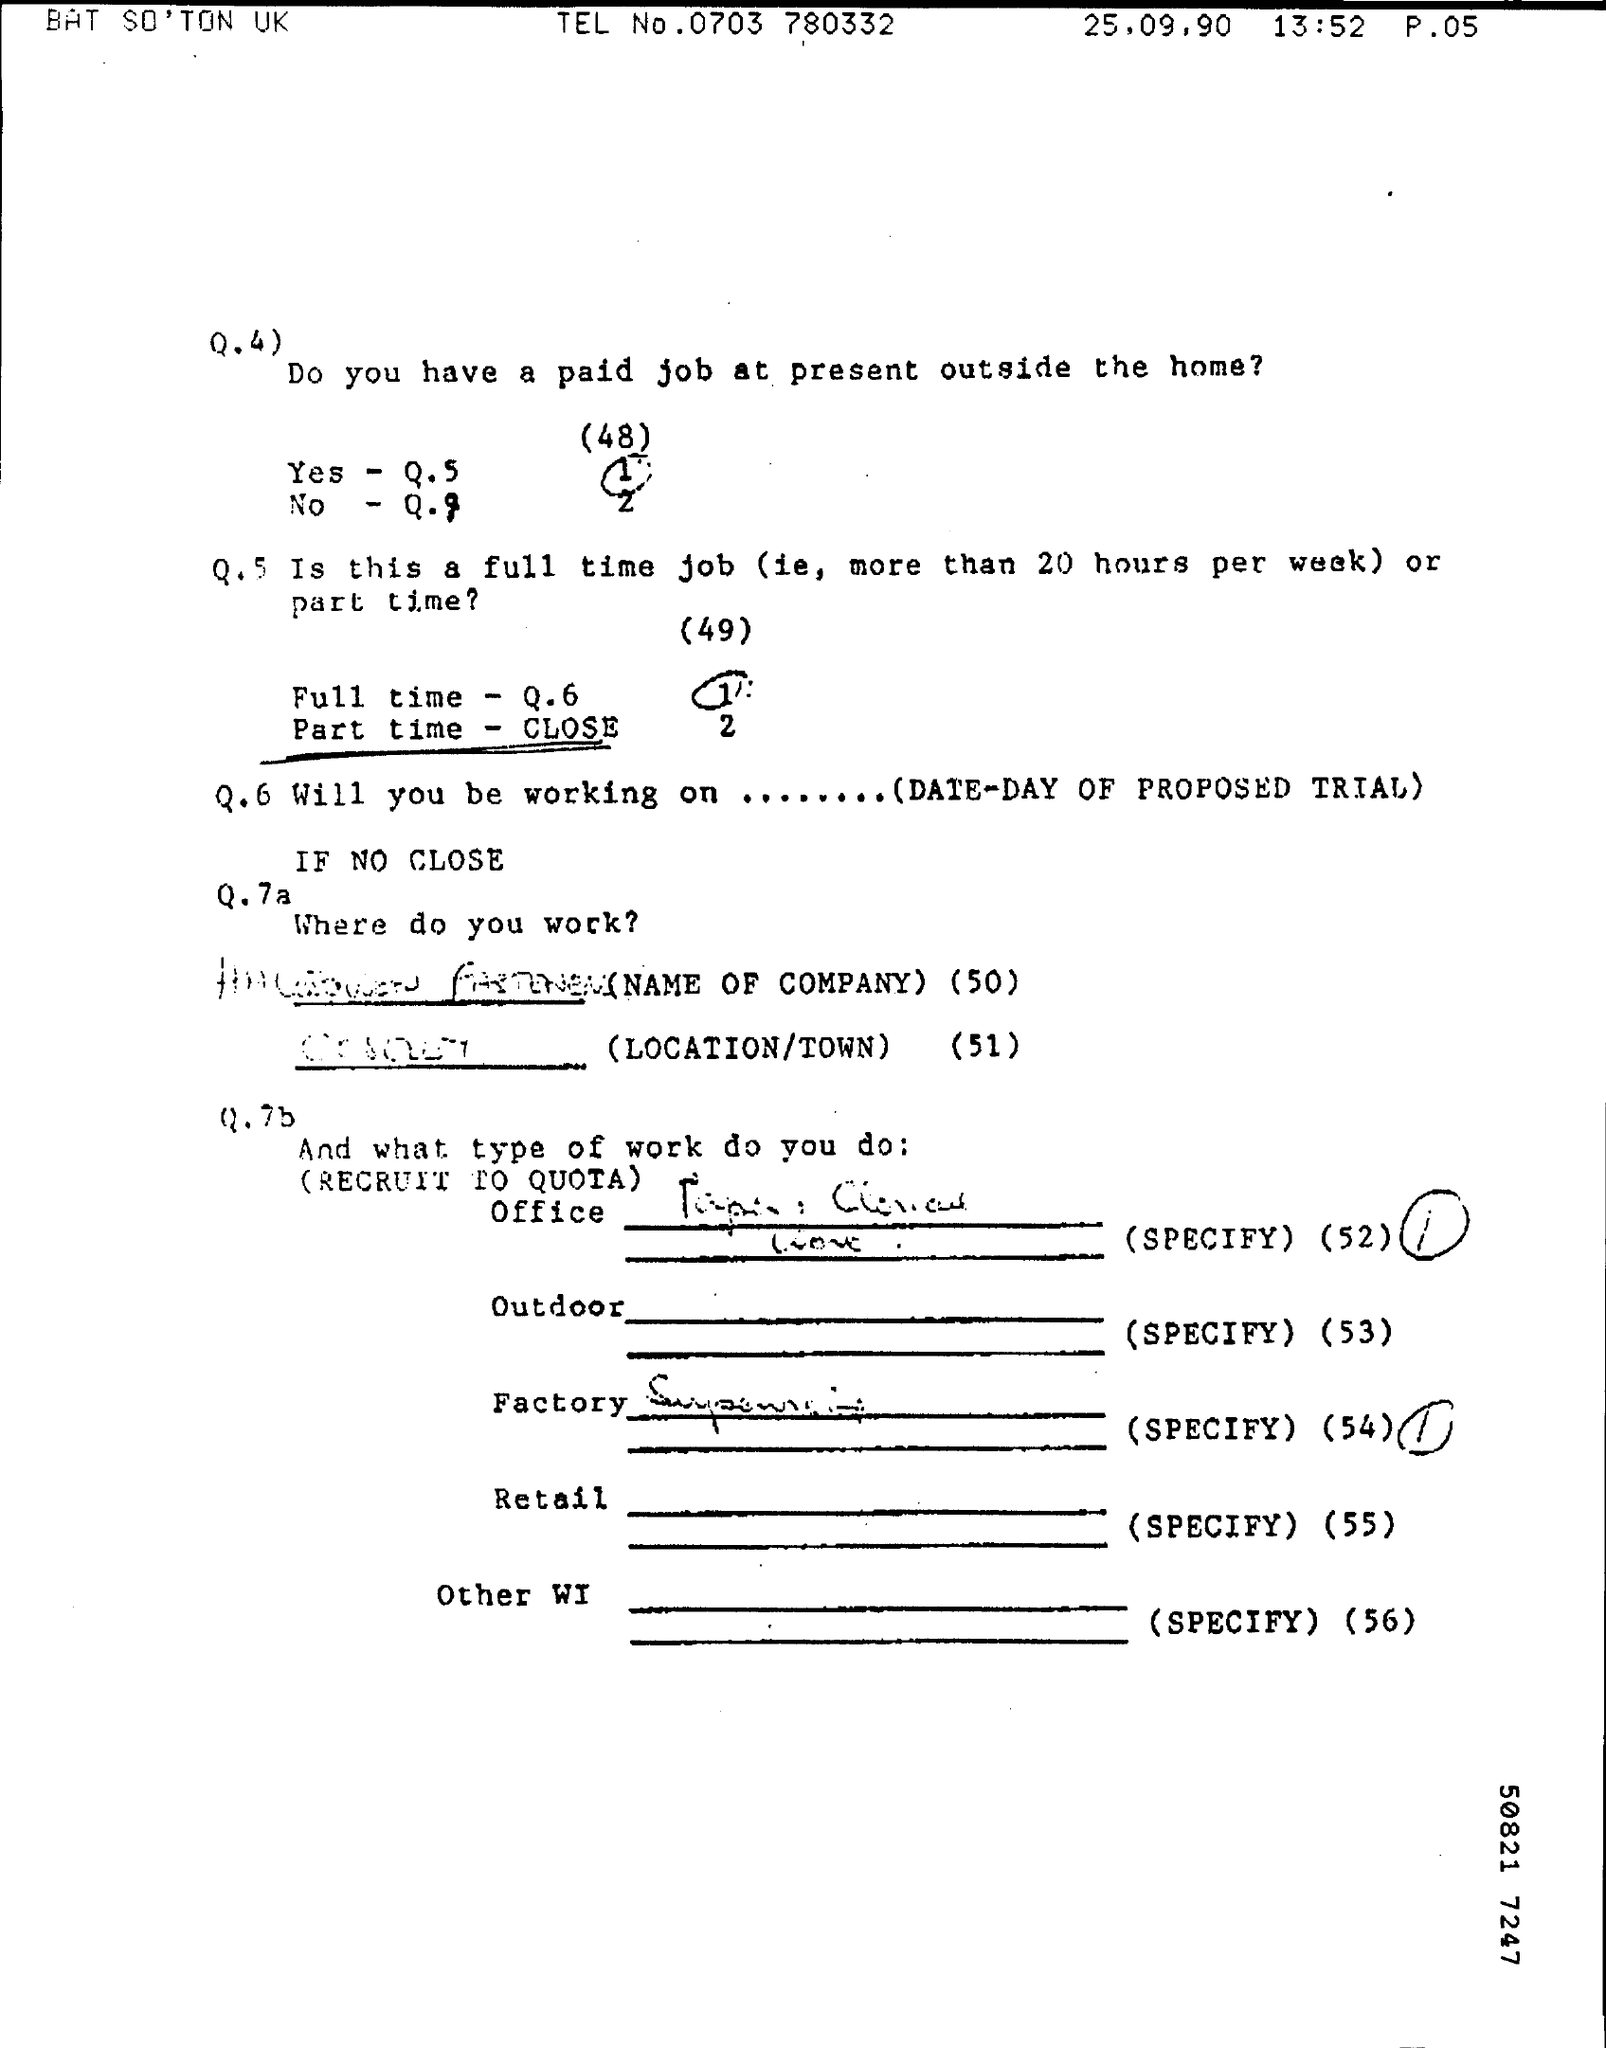Highlight a few significant elements in this photo. The person being asked the questions has a paid job outside the home. 